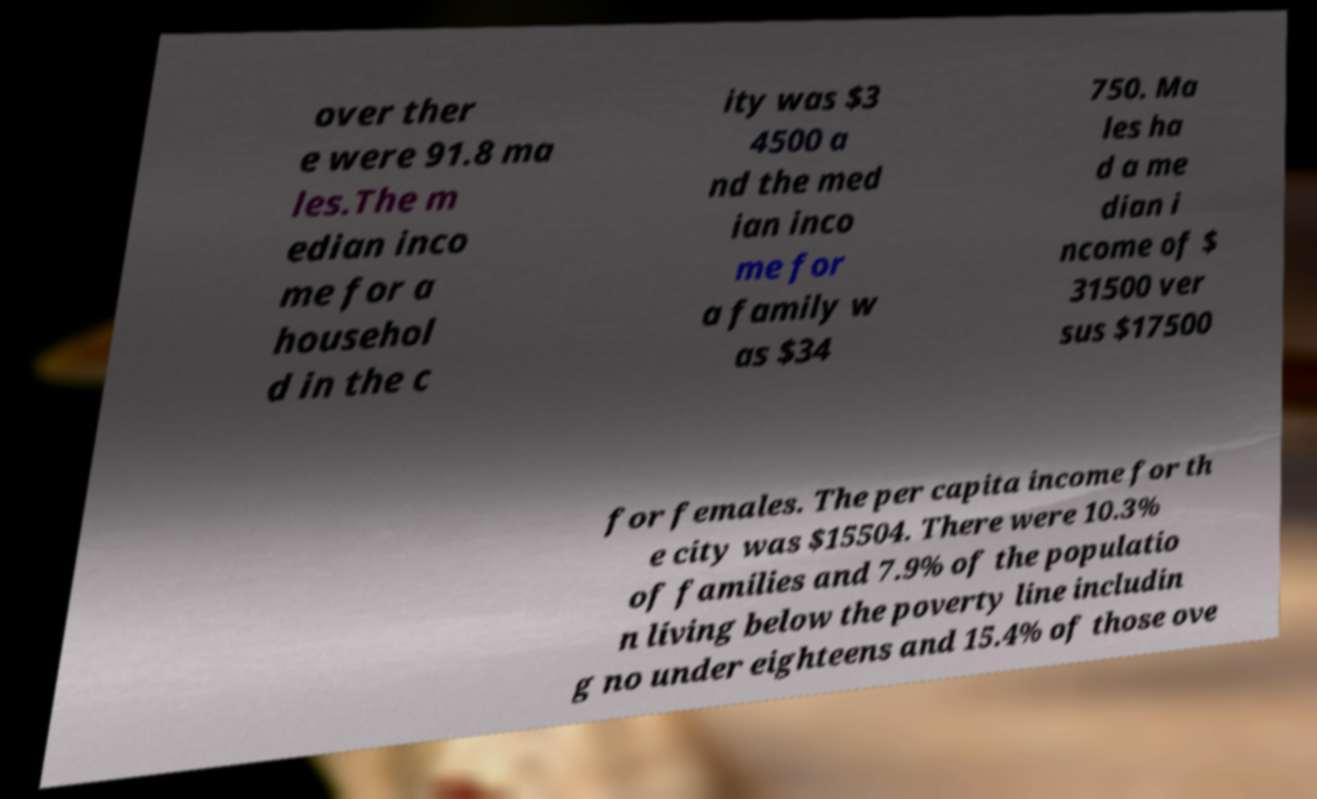For documentation purposes, I need the text within this image transcribed. Could you provide that? over ther e were 91.8 ma les.The m edian inco me for a househol d in the c ity was $3 4500 a nd the med ian inco me for a family w as $34 750. Ma les ha d a me dian i ncome of $ 31500 ver sus $17500 for females. The per capita income for th e city was $15504. There were 10.3% of families and 7.9% of the populatio n living below the poverty line includin g no under eighteens and 15.4% of those ove 